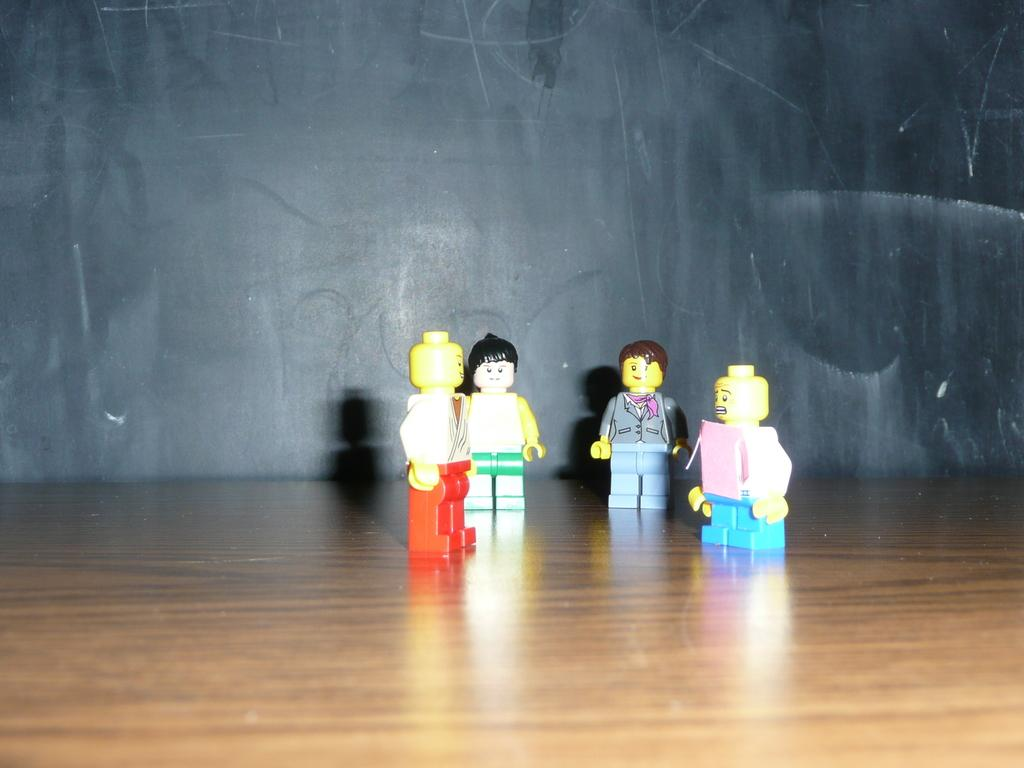How many toys are present in the image? There are four toys in the image. What can be seen in the background of the image? The background of the image is black. What type of attraction is depicted in the image? There is no attraction present in the image; it features four toys against a black background. How many babies are visible in the image? There are no babies present in the image; it features four toys against a black background. 